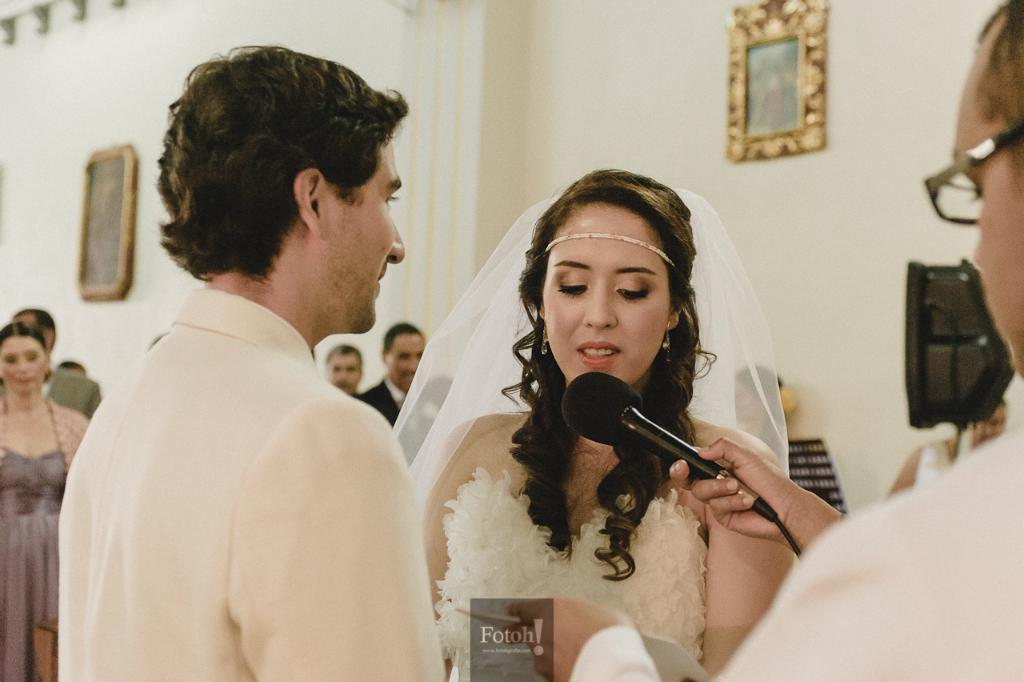How many people are in the image? There are people in the image, but the exact number is not specified. What is one person doing in the image? One person is holding a mic in the image. What device is used to capture the scene in the image? There is a camera in the image. What type of decoration is on the wall in the image? There are photo frames on the wall in the image. What can be seen in addition to the people and objects in the image? There is text visible in the image. What type of rat can be seen interacting with the camera in the image? There is no rat present in the image; it features people, a mic, a camera, photo frames, and text. What type of beast is playing the rhythm on the wall in the image? There is no beast or rhythmic activity depicted on the wall in the image; it only shows photo frames. 